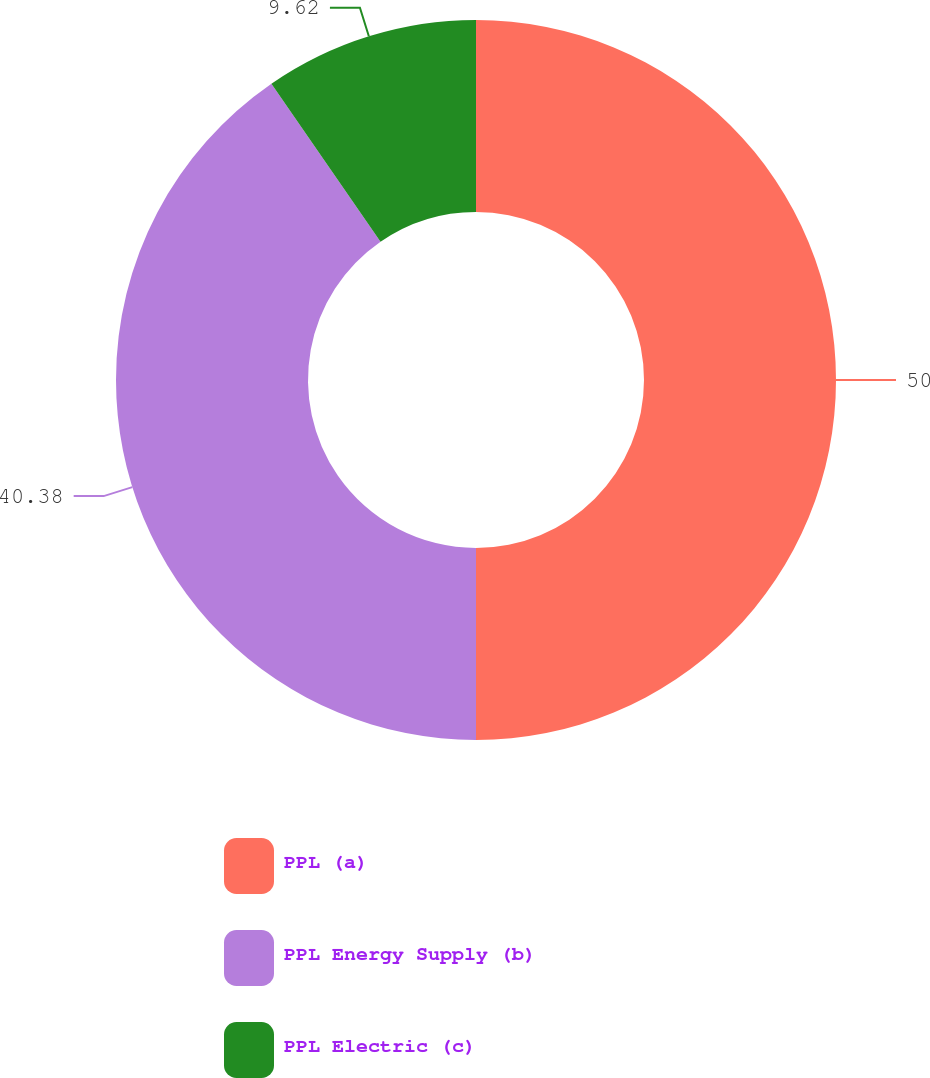Convert chart. <chart><loc_0><loc_0><loc_500><loc_500><pie_chart><fcel>PPL (a)<fcel>PPL Energy Supply (b)<fcel>PPL Electric (c)<nl><fcel>50.0%<fcel>40.38%<fcel>9.62%<nl></chart> 